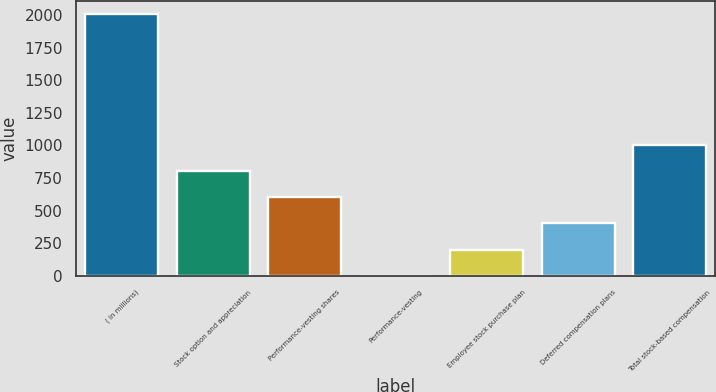<chart> <loc_0><loc_0><loc_500><loc_500><bar_chart><fcel>( in millions)<fcel>Stock option and appreciation<fcel>Performance-vesting shares<fcel>Performance-vesting<fcel>Employee stock purchase plan<fcel>Deferred compensation plans<fcel>Total stock-based compensation<nl><fcel>2010<fcel>804.12<fcel>603.14<fcel>0.2<fcel>201.18<fcel>402.16<fcel>1005.1<nl></chart> 